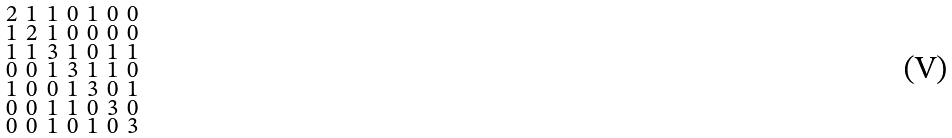<formula> <loc_0><loc_0><loc_500><loc_500>\begin{smallmatrix} 2 & 1 & 1 & 0 & 1 & 0 & 0 \\ 1 & 2 & 1 & 0 & 0 & 0 & 0 \\ 1 & 1 & 3 & 1 & 0 & 1 & 1 \\ 0 & 0 & 1 & 3 & 1 & 1 & 0 \\ 1 & 0 & 0 & 1 & 3 & 0 & 1 \\ 0 & 0 & 1 & 1 & 0 & 3 & 0 \\ 0 & 0 & 1 & 0 & 1 & 0 & 3 \end{smallmatrix}</formula> 